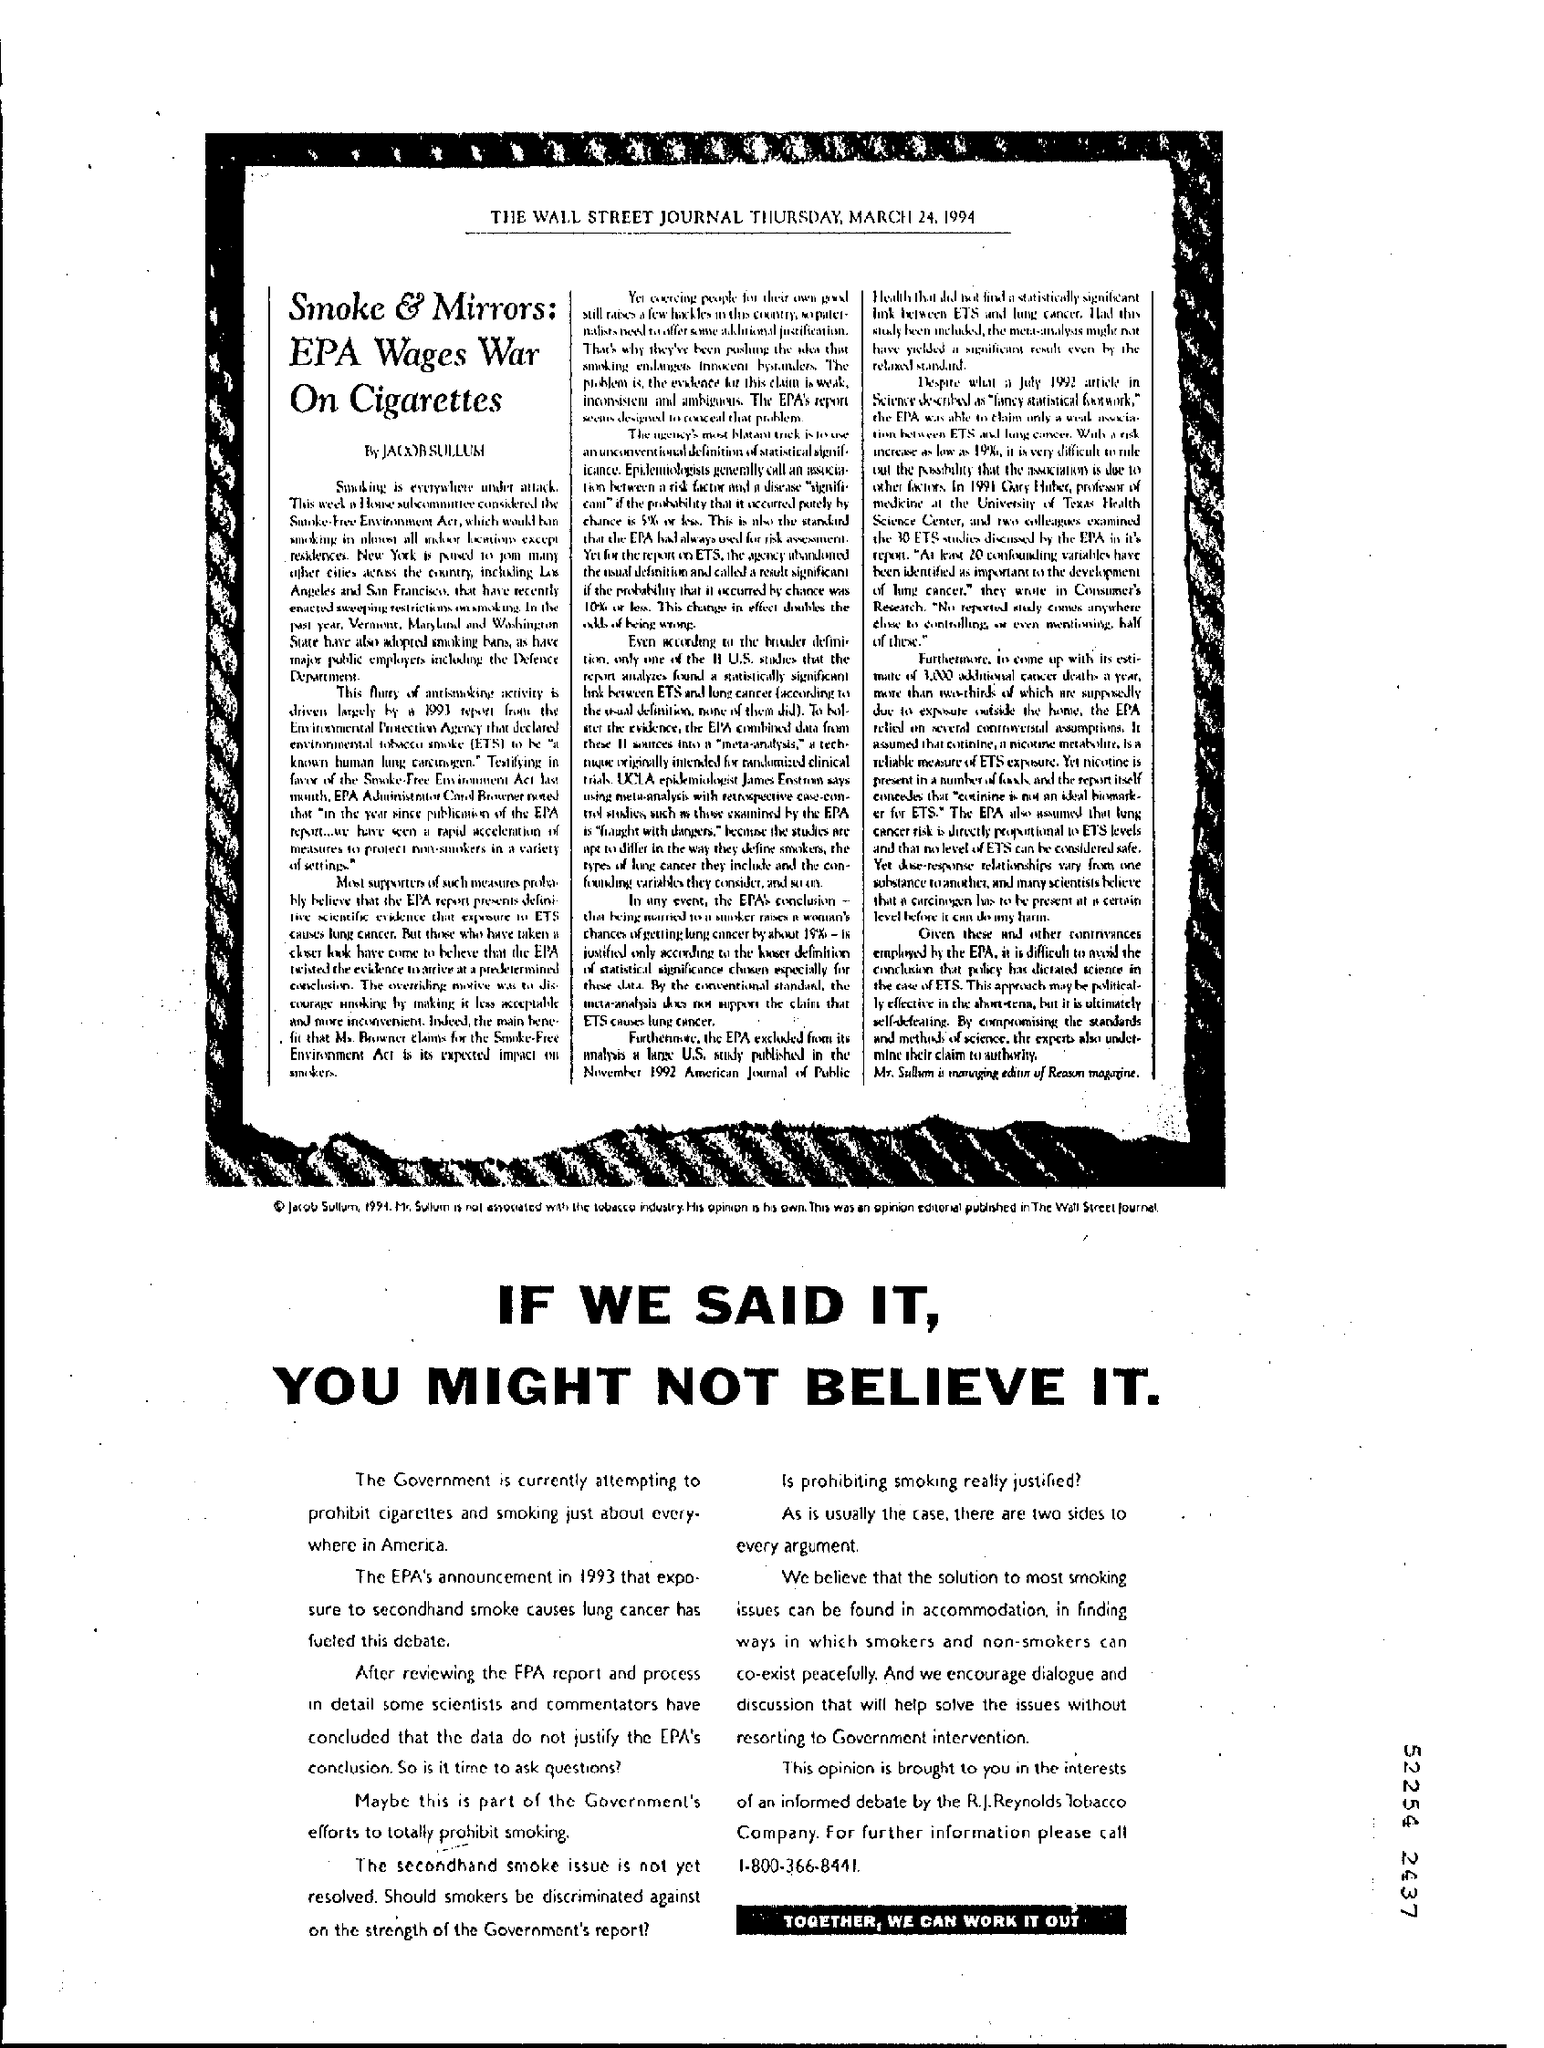From which newspaper is this taken from?
Your answer should be compact. The wall street journal. Which edition of the Wall Street Journal is the article from?
Provide a short and direct response. The wall street journal thursday, march 24, 1994. Who has written the article?
Your answer should be compact. Jacob Sullum. What is the title of the news piece?
Keep it short and to the point. Smoke & Mirrors: EPA Wages War On Cigarettes. 